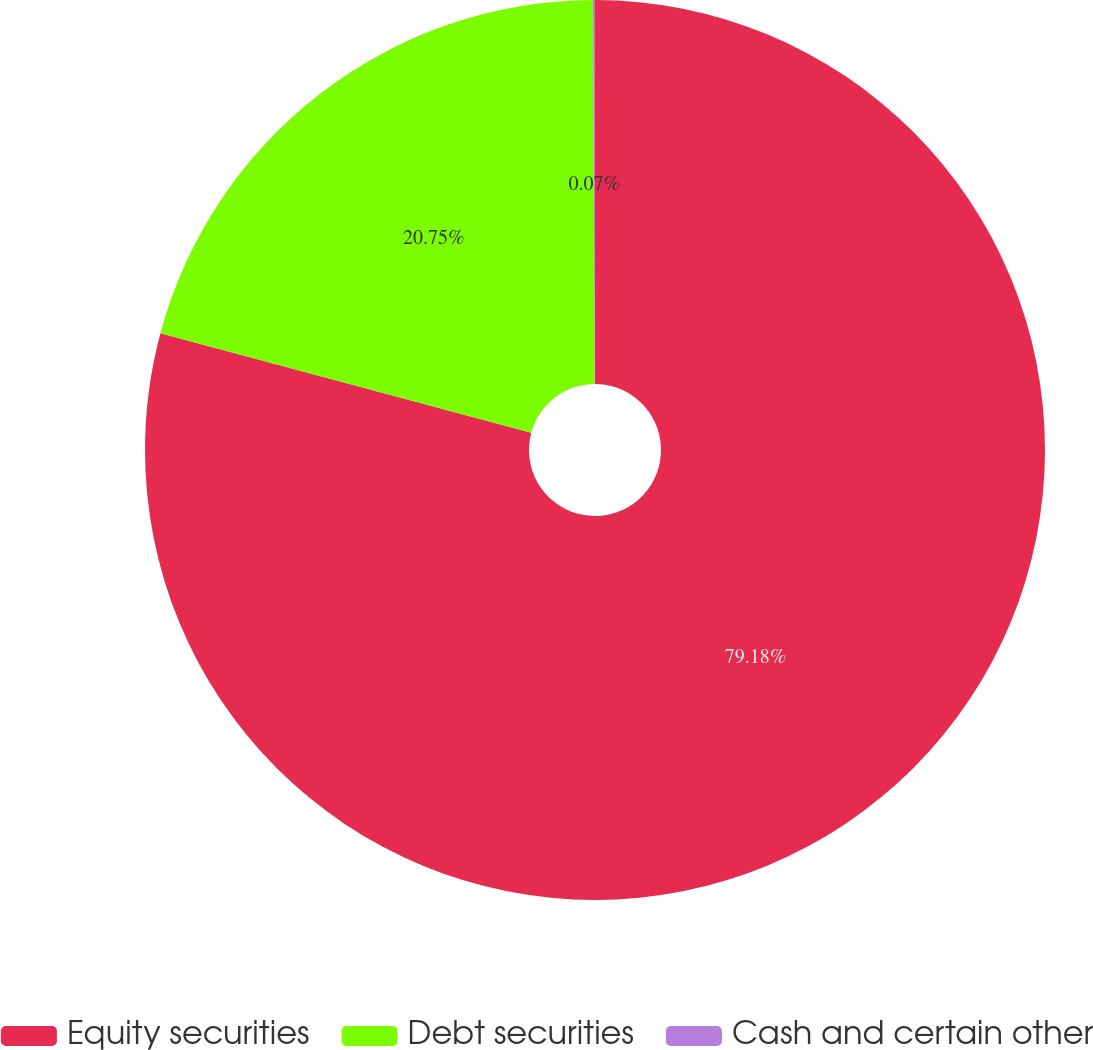<chart> <loc_0><loc_0><loc_500><loc_500><pie_chart><fcel>Equity securities<fcel>Debt securities<fcel>Cash and certain other<nl><fcel>79.18%<fcel>20.75%<fcel>0.07%<nl></chart> 